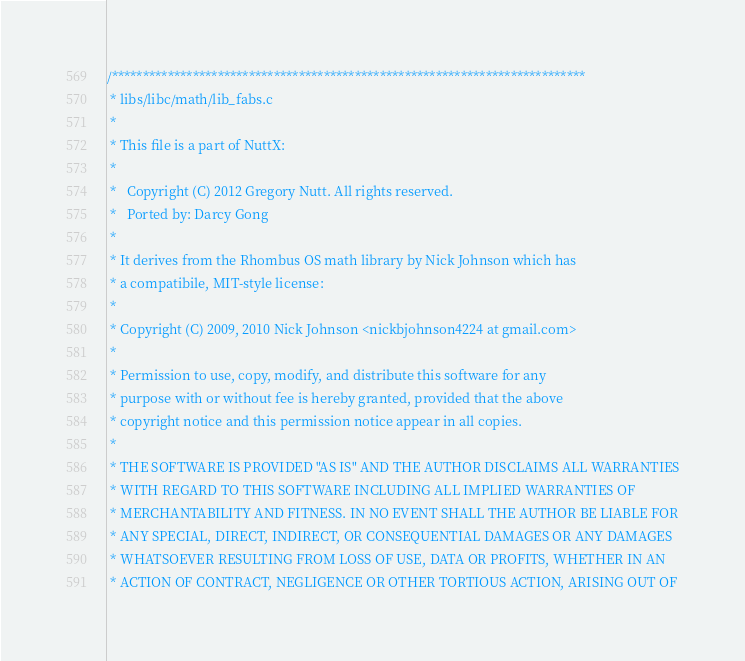Convert code to text. <code><loc_0><loc_0><loc_500><loc_500><_C_>/****************************************************************************
 * libs/libc/math/lib_fabs.c
 *
 * This file is a part of NuttX:
 *
 *   Copyright (C) 2012 Gregory Nutt. All rights reserved.
 *   Ported by: Darcy Gong
 *
 * It derives from the Rhombus OS math library by Nick Johnson which has
 * a compatibile, MIT-style license:
 *
 * Copyright (C) 2009, 2010 Nick Johnson <nickbjohnson4224 at gmail.com>
 *
 * Permission to use, copy, modify, and distribute this software for any
 * purpose with or without fee is hereby granted, provided that the above
 * copyright notice and this permission notice appear in all copies.
 *
 * THE SOFTWARE IS PROVIDED "AS IS" AND THE AUTHOR DISCLAIMS ALL WARRANTIES
 * WITH REGARD TO THIS SOFTWARE INCLUDING ALL IMPLIED WARRANTIES OF
 * MERCHANTABILITY AND FITNESS. IN NO EVENT SHALL THE AUTHOR BE LIABLE FOR
 * ANY SPECIAL, DIRECT, INDIRECT, OR CONSEQUENTIAL DAMAGES OR ANY DAMAGES
 * WHATSOEVER RESULTING FROM LOSS OF USE, DATA OR PROFITS, WHETHER IN AN
 * ACTION OF CONTRACT, NEGLIGENCE OR OTHER TORTIOUS ACTION, ARISING OUT OF</code> 